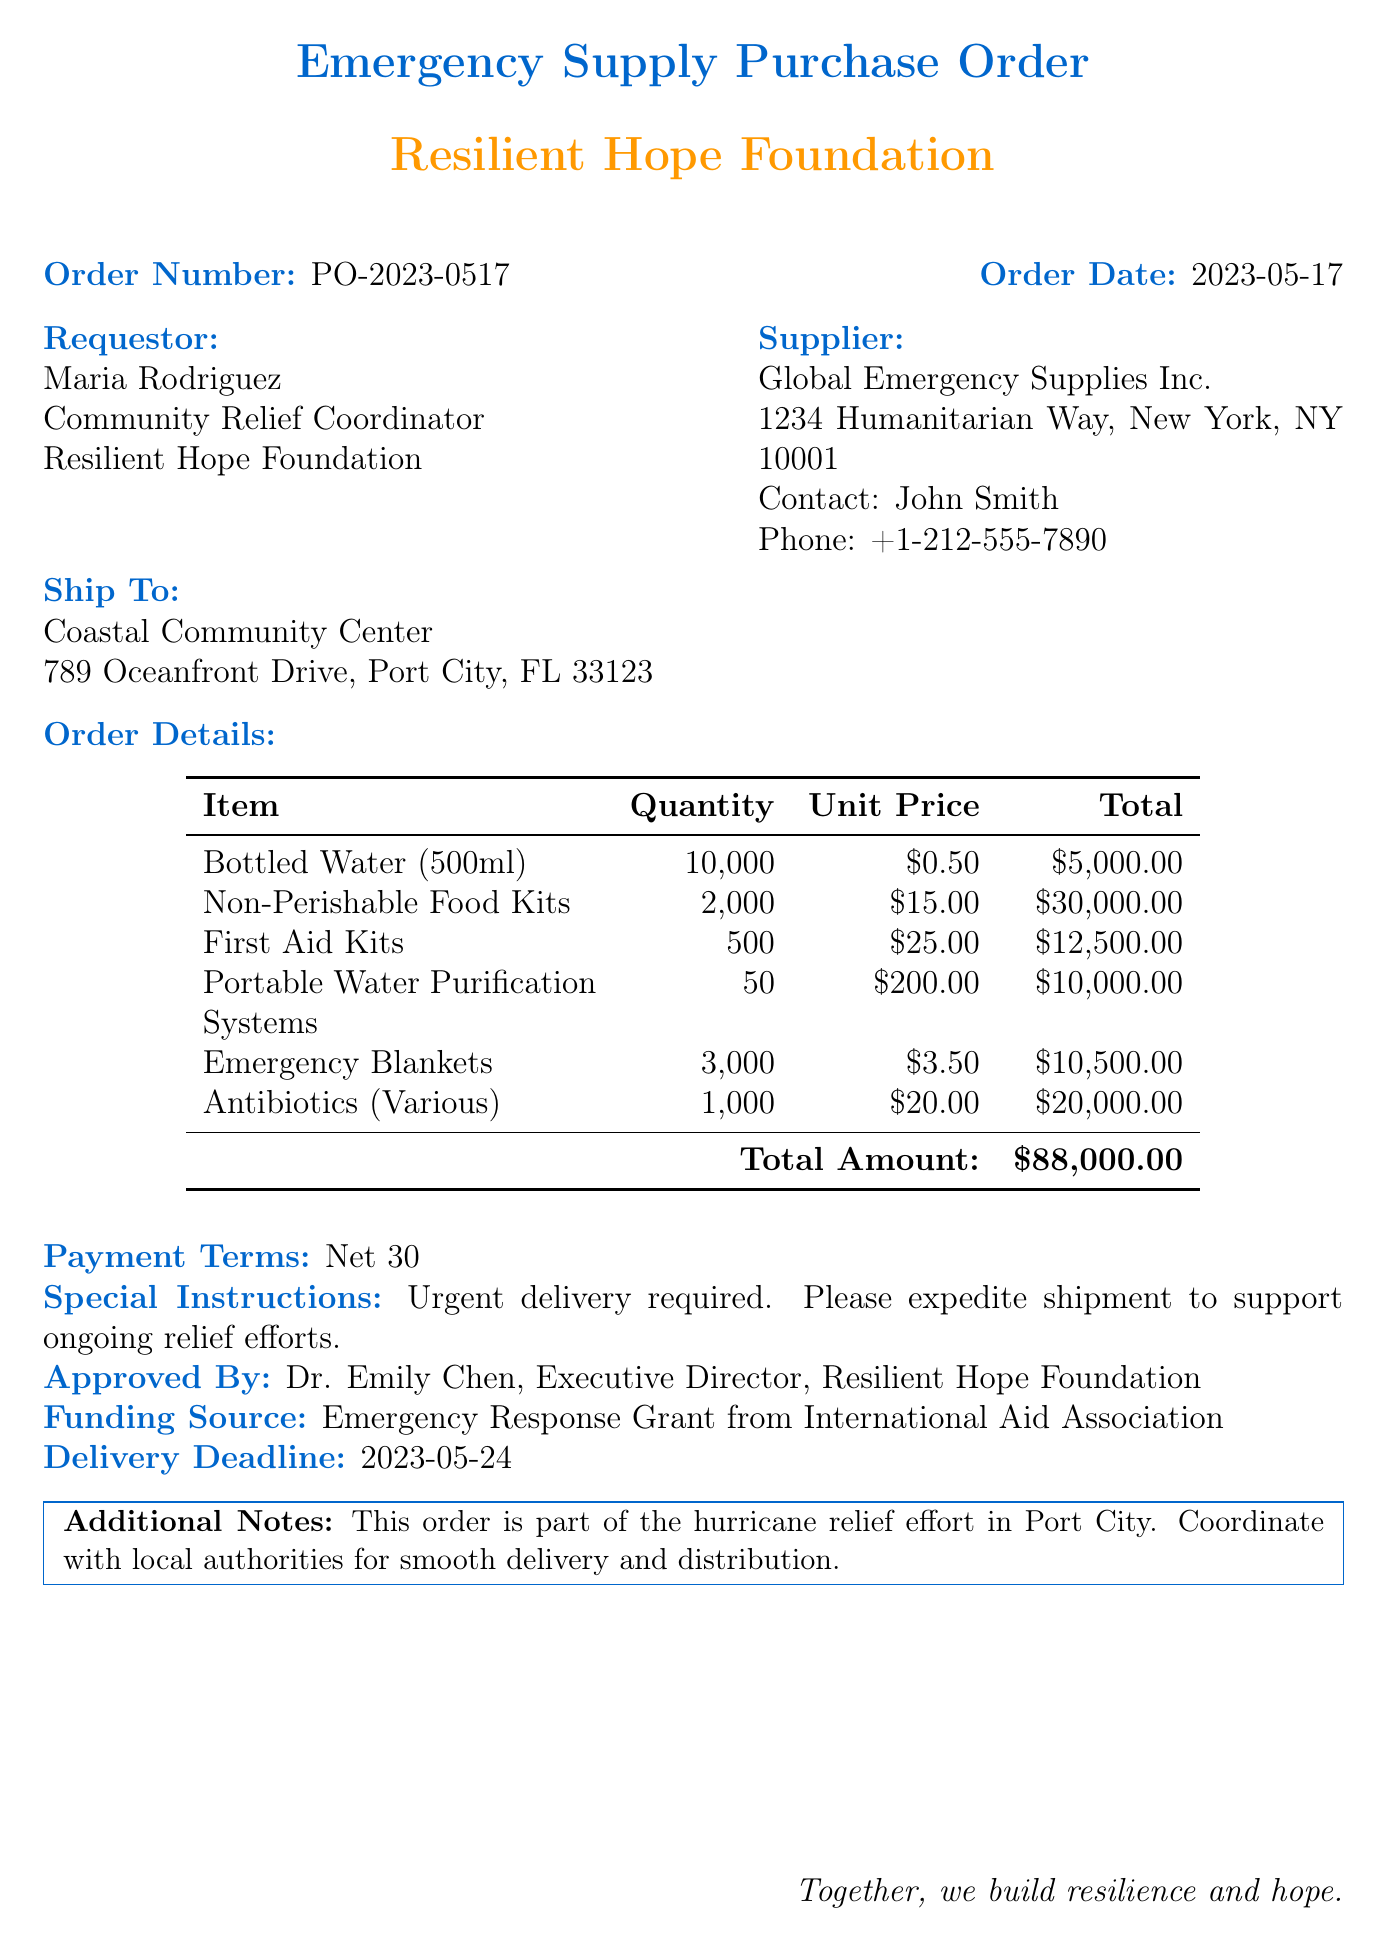What is the order number? The order number is explicitly stated in the document as part of the header information.
Answer: PO-2023-0517 Who is the requestor? The requestor's name is directly mentioned in the document under the requestor section.
Answer: Maria Rodriguez What is the total amount of the order? The total amount is calculated by summing the total prices of all items listed in the order details.
Answer: $88,000.00 What is the delivery deadline? The delivery deadline is specified in the document for timely delivery of the supplies.
Answer: 2023-05-24 How many first aid kits are ordered? The quantity of first aid kits is provided in the order details section, along with other items.
Answer: 500 What is the funding source? The funding source is clearly stated in the document to indicate where the funds are coming from.
Answer: Emergency Response Grant from International Aid Association What are the payment terms? The payment terms are mentioned in the document for the order's financial agreement.
Answer: Net 30 Which organization is the supplier? The supplier's organization name is given clearly in the supplier section of the document.
Answer: Global Emergency Supplies Inc What is the special instruction noted in the order? The special instructions provide specific requests regarding the urgency of the order and its shipment.
Answer: Urgent delivery required. Please expedite shipment to support ongoing relief efforts 